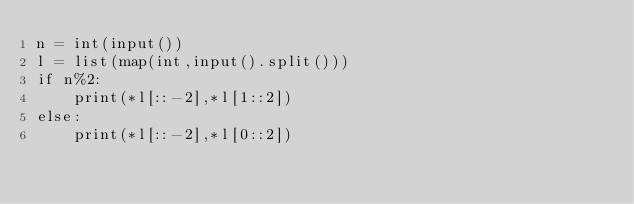<code> <loc_0><loc_0><loc_500><loc_500><_Python_>n = int(input())
l = list(map(int,input().split()))
if n%2:
    print(*l[::-2],*l[1::2])
else:
    print(*l[::-2],*l[0::2])</code> 